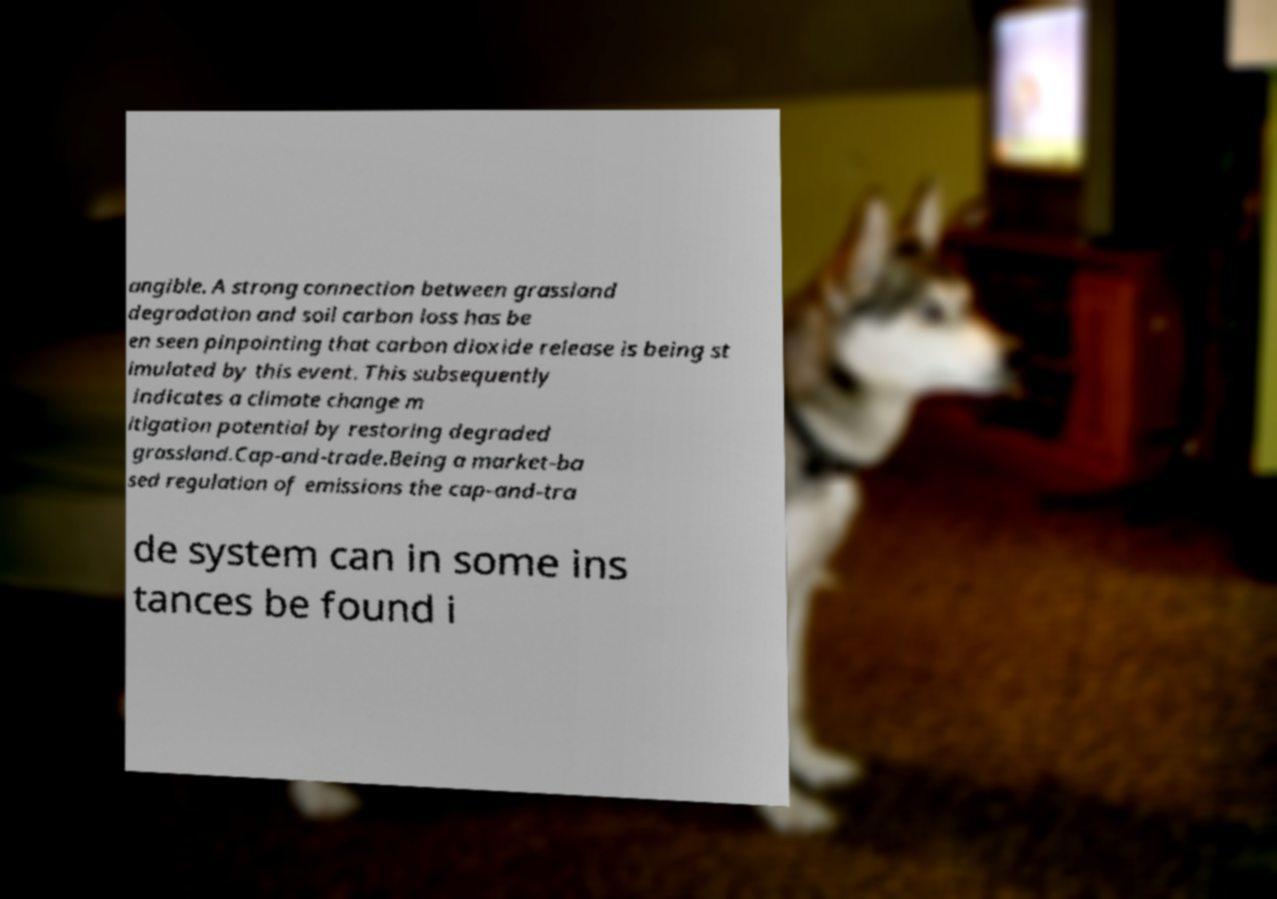Please read and relay the text visible in this image. What does it say? angible. A strong connection between grassland degradation and soil carbon loss has be en seen pinpointing that carbon dioxide release is being st imulated by this event. This subsequently indicates a climate change m itigation potential by restoring degraded grassland.Cap-and-trade.Being a market-ba sed regulation of emissions the cap-and-tra de system can in some ins tances be found i 